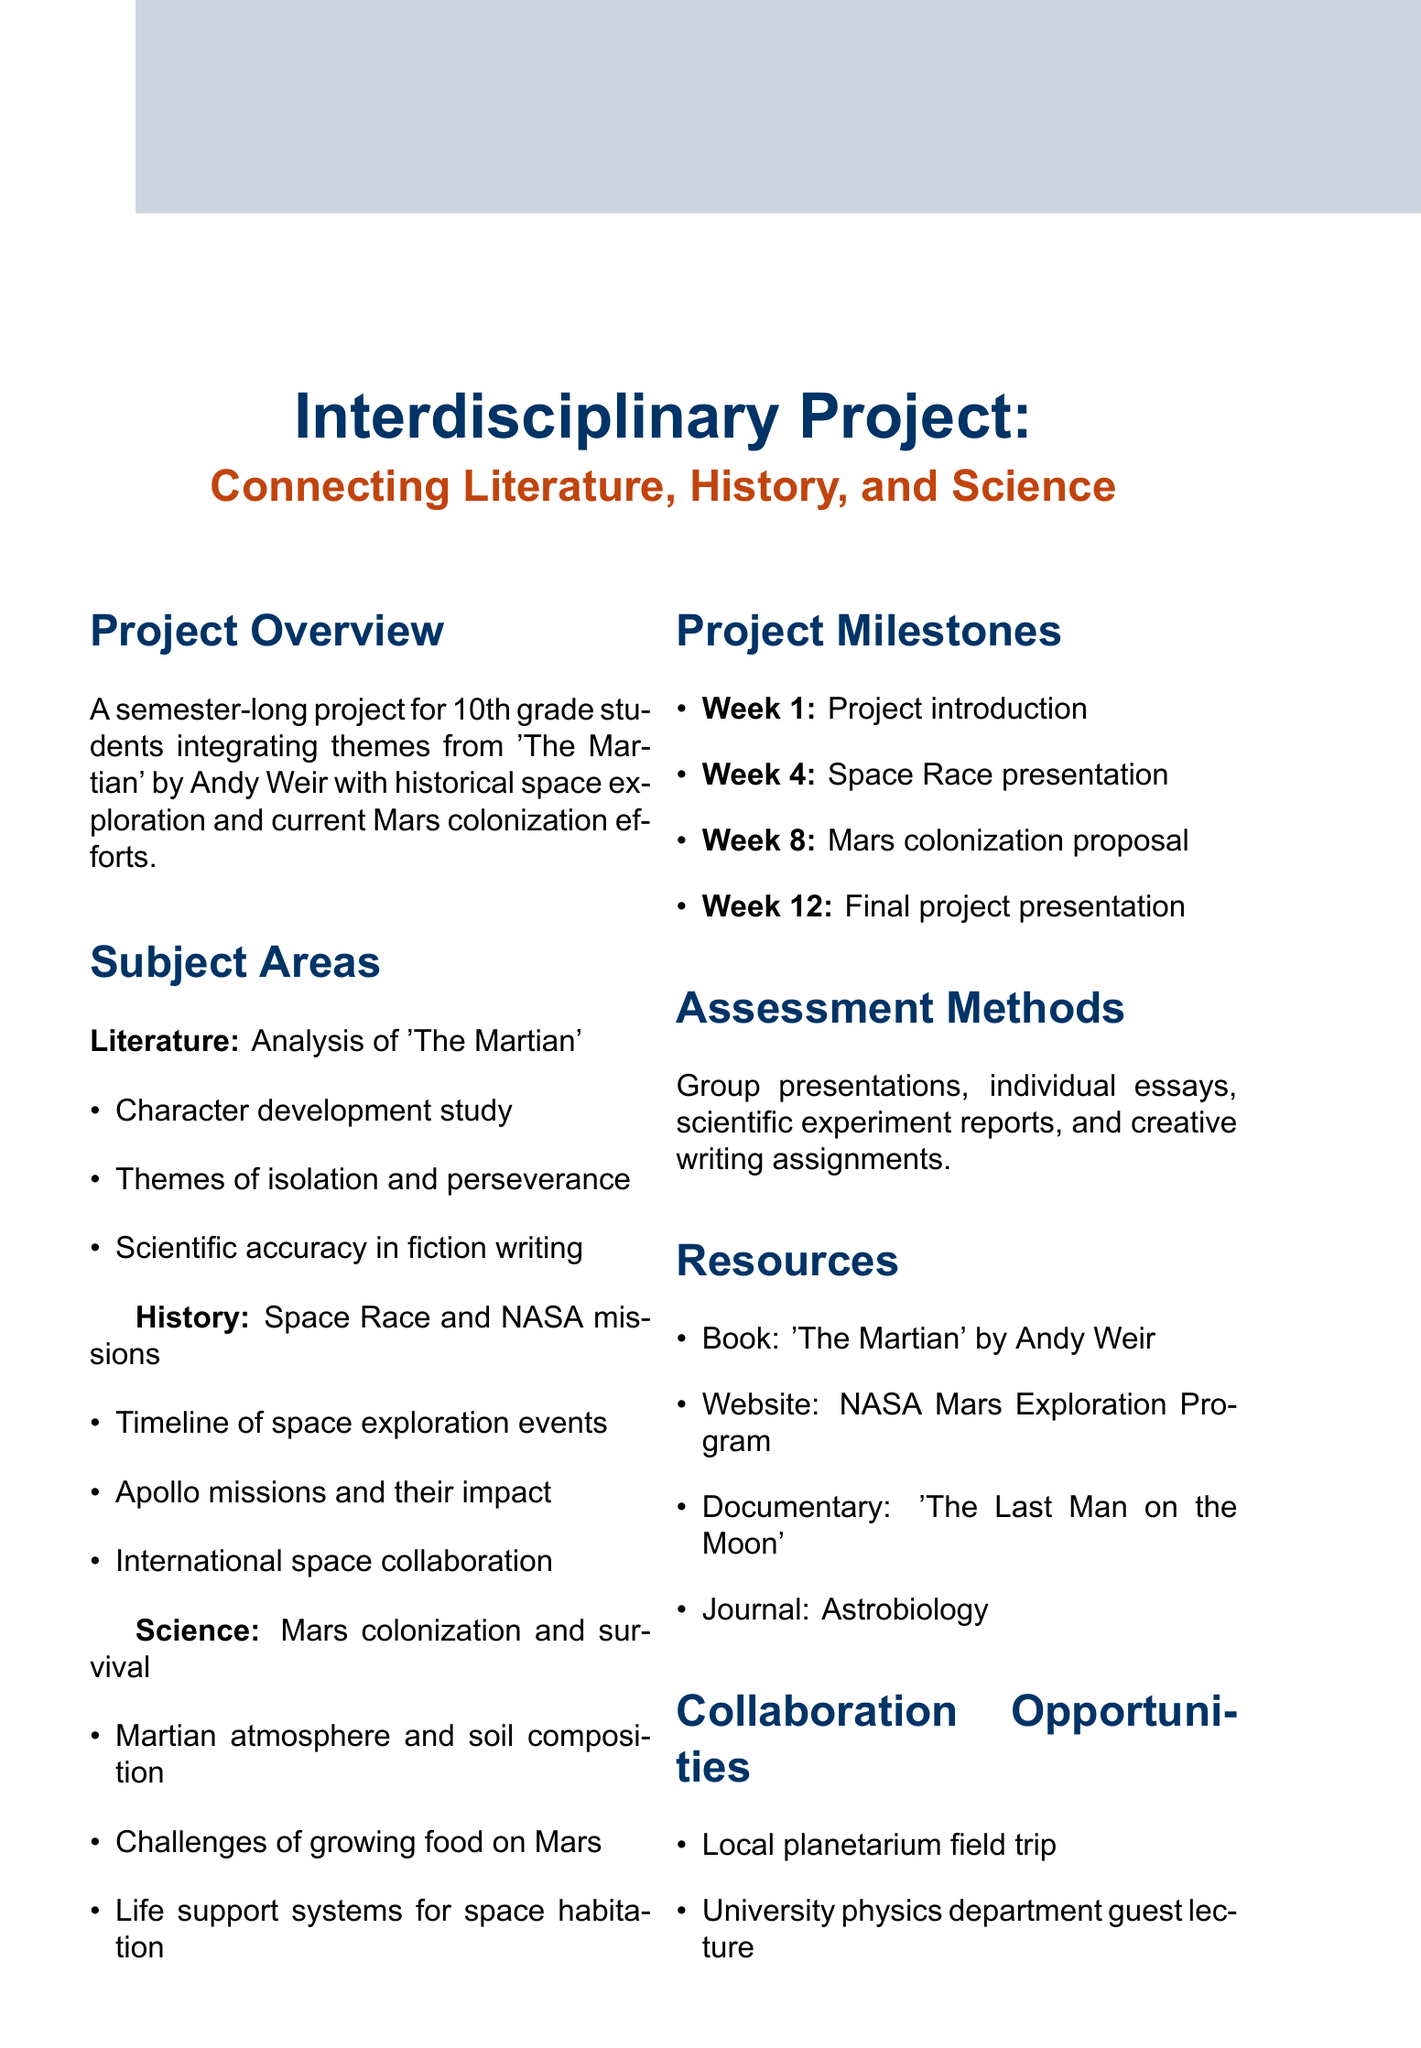What is the project title? The project title is clearly stated at the beginning of the document, which is "Interdisciplinary Project: Connecting Literature, History, and Science."
Answer: Interdisciplinary Project: Connecting Literature, History, and Science What book is analyzed in the literature section? The literature section specifically mentions the book that will be analyzed, which is "The Martian" by Andy Weir.
Answer: The Martian What week is the final project presentation scheduled? The document outlines milestone weeks, with the final project presentation scheduled for week 12.
Answer: 12 What are the subjects involved in the project? The document lists the subject areas involved in the project as Literature, History, and Science.
Answer: Literature, History, and Science What is one activity mentioned for parental involvement? The document details various parental involvement activities, and one mentioned is a "Parent-led workshop on real-world applications of interdisciplinary thinking."
Answer: Parent-led workshop on real-world applications of interdisciplinary thinking What is the target grade level for this project? The target grade level is specified as 10th grade in the project overview section.
Answer: 10th grade How many weeks is the project scheduled to last? The project is described as a semester-long project, typically lasting around 12 weeks, as indicated by the milestones.
Answer: 12 weeks What type of document is this? The document is a memo outlining an educational project, as indicated by its title and content structure.
Answer: Memo 